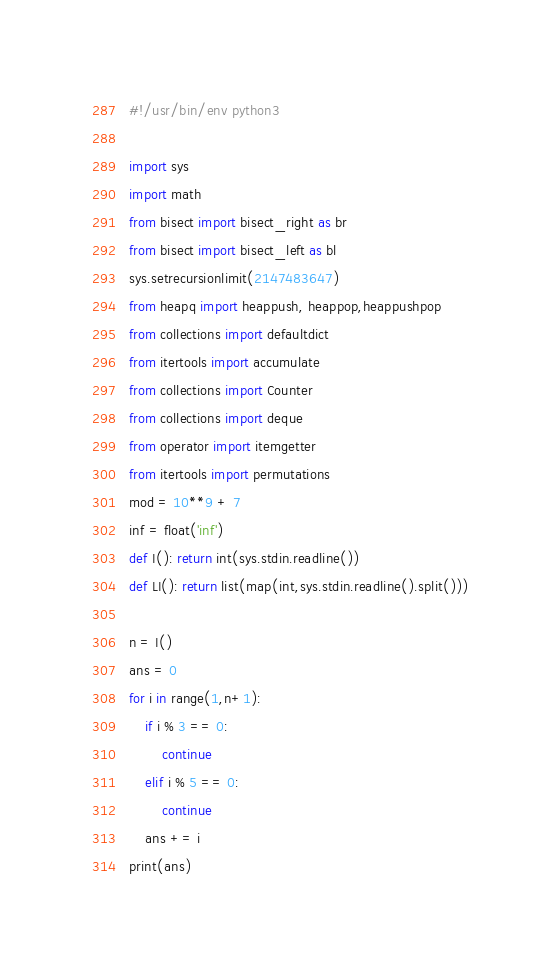<code> <loc_0><loc_0><loc_500><loc_500><_Python_>#!/usr/bin/env python3

import sys
import math
from bisect import bisect_right as br
from bisect import bisect_left as bl
sys.setrecursionlimit(2147483647)
from heapq import heappush, heappop,heappushpop
from collections import defaultdict
from itertools import accumulate
from collections import Counter
from collections import deque
from operator import itemgetter
from itertools import permutations
mod = 10**9 + 7
inf = float('inf')
def I(): return int(sys.stdin.readline())
def LI(): return list(map(int,sys.stdin.readline().split()))

n = I()
ans = 0
for i in range(1,n+1):
    if i % 3 == 0:
        continue
    elif i % 5 == 0:
        continue
    ans += i
print(ans)</code> 